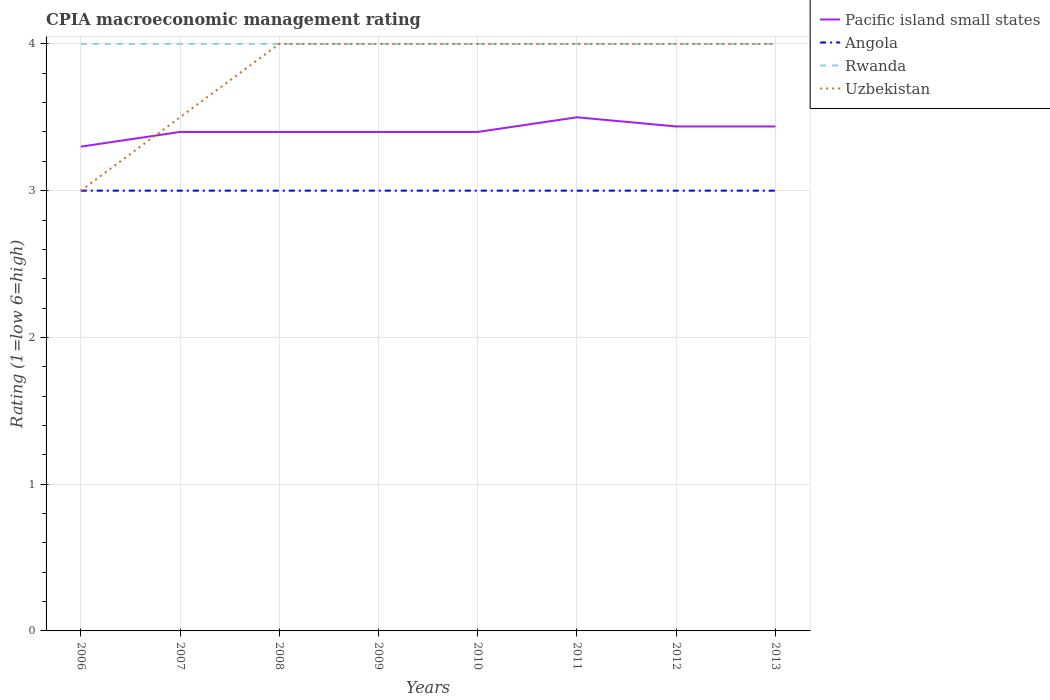Does the line corresponding to Rwanda intersect with the line corresponding to Uzbekistan?
Provide a succinct answer. Yes. Across all years, what is the maximum CPIA rating in Pacific island small states?
Provide a short and direct response. 3.3. What is the difference between the highest and the second highest CPIA rating in Uzbekistan?
Provide a succinct answer. 1. What is the difference between the highest and the lowest CPIA rating in Angola?
Your answer should be very brief. 0. Is the CPIA rating in Angola strictly greater than the CPIA rating in Uzbekistan over the years?
Make the answer very short. No. How many lines are there?
Offer a very short reply. 4. What is the difference between two consecutive major ticks on the Y-axis?
Give a very brief answer. 1. Does the graph contain grids?
Your answer should be compact. Yes. Where does the legend appear in the graph?
Your answer should be very brief. Top right. How are the legend labels stacked?
Your response must be concise. Vertical. What is the title of the graph?
Your answer should be very brief. CPIA macroeconomic management rating. Does "United States" appear as one of the legend labels in the graph?
Your answer should be compact. No. What is the label or title of the Y-axis?
Give a very brief answer. Rating (1=low 6=high). What is the Rating (1=low 6=high) in Uzbekistan in 2006?
Your answer should be very brief. 3. What is the Rating (1=low 6=high) in Rwanda in 2007?
Provide a succinct answer. 4. What is the Rating (1=low 6=high) of Uzbekistan in 2007?
Provide a short and direct response. 3.5. What is the Rating (1=low 6=high) in Angola in 2008?
Your answer should be very brief. 3. What is the Rating (1=low 6=high) in Rwanda in 2008?
Your answer should be very brief. 4. What is the Rating (1=low 6=high) in Uzbekistan in 2008?
Your response must be concise. 4. What is the Rating (1=low 6=high) in Pacific island small states in 2009?
Make the answer very short. 3.4. What is the Rating (1=low 6=high) in Rwanda in 2009?
Ensure brevity in your answer.  4. What is the Rating (1=low 6=high) in Pacific island small states in 2010?
Provide a short and direct response. 3.4. What is the Rating (1=low 6=high) of Uzbekistan in 2010?
Provide a short and direct response. 4. What is the Rating (1=low 6=high) of Pacific island small states in 2011?
Your answer should be compact. 3.5. What is the Rating (1=low 6=high) in Angola in 2011?
Ensure brevity in your answer.  3. What is the Rating (1=low 6=high) in Pacific island small states in 2012?
Provide a short and direct response. 3.44. What is the Rating (1=low 6=high) of Uzbekistan in 2012?
Provide a short and direct response. 4. What is the Rating (1=low 6=high) of Pacific island small states in 2013?
Give a very brief answer. 3.44. What is the Rating (1=low 6=high) of Rwanda in 2013?
Ensure brevity in your answer.  4. What is the Rating (1=low 6=high) in Uzbekistan in 2013?
Offer a very short reply. 4. Across all years, what is the maximum Rating (1=low 6=high) of Uzbekistan?
Offer a terse response. 4. Across all years, what is the minimum Rating (1=low 6=high) in Uzbekistan?
Provide a short and direct response. 3. What is the total Rating (1=low 6=high) of Pacific island small states in the graph?
Your answer should be very brief. 27.27. What is the total Rating (1=low 6=high) of Angola in the graph?
Give a very brief answer. 24. What is the total Rating (1=low 6=high) of Rwanda in the graph?
Keep it short and to the point. 32. What is the total Rating (1=low 6=high) in Uzbekistan in the graph?
Provide a short and direct response. 30.5. What is the difference between the Rating (1=low 6=high) of Pacific island small states in 2006 and that in 2007?
Ensure brevity in your answer.  -0.1. What is the difference between the Rating (1=low 6=high) of Uzbekistan in 2006 and that in 2007?
Offer a terse response. -0.5. What is the difference between the Rating (1=low 6=high) in Rwanda in 2006 and that in 2009?
Your answer should be very brief. 0. What is the difference between the Rating (1=low 6=high) in Uzbekistan in 2006 and that in 2009?
Your response must be concise. -1. What is the difference between the Rating (1=low 6=high) in Angola in 2006 and that in 2010?
Give a very brief answer. 0. What is the difference between the Rating (1=low 6=high) in Rwanda in 2006 and that in 2010?
Offer a terse response. 0. What is the difference between the Rating (1=low 6=high) in Pacific island small states in 2006 and that in 2011?
Ensure brevity in your answer.  -0.2. What is the difference between the Rating (1=low 6=high) of Angola in 2006 and that in 2011?
Ensure brevity in your answer.  0. What is the difference between the Rating (1=low 6=high) in Rwanda in 2006 and that in 2011?
Provide a short and direct response. 0. What is the difference between the Rating (1=low 6=high) in Pacific island small states in 2006 and that in 2012?
Offer a terse response. -0.14. What is the difference between the Rating (1=low 6=high) of Angola in 2006 and that in 2012?
Provide a succinct answer. 0. What is the difference between the Rating (1=low 6=high) of Rwanda in 2006 and that in 2012?
Ensure brevity in your answer.  0. What is the difference between the Rating (1=low 6=high) of Uzbekistan in 2006 and that in 2012?
Offer a terse response. -1. What is the difference between the Rating (1=low 6=high) of Pacific island small states in 2006 and that in 2013?
Provide a short and direct response. -0.14. What is the difference between the Rating (1=low 6=high) in Angola in 2006 and that in 2013?
Keep it short and to the point. 0. What is the difference between the Rating (1=low 6=high) of Uzbekistan in 2006 and that in 2013?
Your answer should be very brief. -1. What is the difference between the Rating (1=low 6=high) in Pacific island small states in 2007 and that in 2008?
Keep it short and to the point. 0. What is the difference between the Rating (1=low 6=high) of Uzbekistan in 2007 and that in 2008?
Your answer should be compact. -0.5. What is the difference between the Rating (1=low 6=high) in Pacific island small states in 2007 and that in 2009?
Keep it short and to the point. 0. What is the difference between the Rating (1=low 6=high) in Uzbekistan in 2007 and that in 2009?
Provide a succinct answer. -0.5. What is the difference between the Rating (1=low 6=high) of Rwanda in 2007 and that in 2010?
Provide a succinct answer. 0. What is the difference between the Rating (1=low 6=high) of Angola in 2007 and that in 2011?
Make the answer very short. 0. What is the difference between the Rating (1=low 6=high) in Rwanda in 2007 and that in 2011?
Make the answer very short. 0. What is the difference between the Rating (1=low 6=high) in Uzbekistan in 2007 and that in 2011?
Your answer should be compact. -0.5. What is the difference between the Rating (1=low 6=high) in Pacific island small states in 2007 and that in 2012?
Offer a very short reply. -0.04. What is the difference between the Rating (1=low 6=high) in Rwanda in 2007 and that in 2012?
Give a very brief answer. 0. What is the difference between the Rating (1=low 6=high) in Pacific island small states in 2007 and that in 2013?
Offer a very short reply. -0.04. What is the difference between the Rating (1=low 6=high) of Angola in 2007 and that in 2013?
Ensure brevity in your answer.  0. What is the difference between the Rating (1=low 6=high) in Pacific island small states in 2008 and that in 2009?
Keep it short and to the point. 0. What is the difference between the Rating (1=low 6=high) in Rwanda in 2008 and that in 2009?
Your response must be concise. 0. What is the difference between the Rating (1=low 6=high) in Uzbekistan in 2008 and that in 2010?
Provide a succinct answer. 0. What is the difference between the Rating (1=low 6=high) in Rwanda in 2008 and that in 2011?
Your response must be concise. 0. What is the difference between the Rating (1=low 6=high) of Pacific island small states in 2008 and that in 2012?
Provide a short and direct response. -0.04. What is the difference between the Rating (1=low 6=high) of Angola in 2008 and that in 2012?
Keep it short and to the point. 0. What is the difference between the Rating (1=low 6=high) in Rwanda in 2008 and that in 2012?
Your answer should be very brief. 0. What is the difference between the Rating (1=low 6=high) in Uzbekistan in 2008 and that in 2012?
Offer a very short reply. 0. What is the difference between the Rating (1=low 6=high) of Pacific island small states in 2008 and that in 2013?
Provide a succinct answer. -0.04. What is the difference between the Rating (1=low 6=high) of Angola in 2008 and that in 2013?
Offer a terse response. 0. What is the difference between the Rating (1=low 6=high) in Rwanda in 2008 and that in 2013?
Your answer should be compact. 0. What is the difference between the Rating (1=low 6=high) of Angola in 2009 and that in 2010?
Your answer should be very brief. 0. What is the difference between the Rating (1=low 6=high) in Rwanda in 2009 and that in 2010?
Give a very brief answer. 0. What is the difference between the Rating (1=low 6=high) of Uzbekistan in 2009 and that in 2010?
Ensure brevity in your answer.  0. What is the difference between the Rating (1=low 6=high) in Pacific island small states in 2009 and that in 2011?
Your answer should be very brief. -0.1. What is the difference between the Rating (1=low 6=high) of Angola in 2009 and that in 2011?
Your answer should be compact. 0. What is the difference between the Rating (1=low 6=high) in Rwanda in 2009 and that in 2011?
Your answer should be very brief. 0. What is the difference between the Rating (1=low 6=high) of Pacific island small states in 2009 and that in 2012?
Provide a succinct answer. -0.04. What is the difference between the Rating (1=low 6=high) of Angola in 2009 and that in 2012?
Provide a succinct answer. 0. What is the difference between the Rating (1=low 6=high) in Pacific island small states in 2009 and that in 2013?
Provide a succinct answer. -0.04. What is the difference between the Rating (1=low 6=high) in Angola in 2009 and that in 2013?
Ensure brevity in your answer.  0. What is the difference between the Rating (1=low 6=high) of Rwanda in 2009 and that in 2013?
Make the answer very short. 0. What is the difference between the Rating (1=low 6=high) in Uzbekistan in 2009 and that in 2013?
Your answer should be very brief. 0. What is the difference between the Rating (1=low 6=high) of Pacific island small states in 2010 and that in 2012?
Offer a very short reply. -0.04. What is the difference between the Rating (1=low 6=high) in Angola in 2010 and that in 2012?
Your answer should be compact. 0. What is the difference between the Rating (1=low 6=high) of Uzbekistan in 2010 and that in 2012?
Provide a short and direct response. 0. What is the difference between the Rating (1=low 6=high) of Pacific island small states in 2010 and that in 2013?
Ensure brevity in your answer.  -0.04. What is the difference between the Rating (1=low 6=high) in Rwanda in 2010 and that in 2013?
Your answer should be very brief. 0. What is the difference between the Rating (1=low 6=high) in Pacific island small states in 2011 and that in 2012?
Your answer should be very brief. 0.06. What is the difference between the Rating (1=low 6=high) of Angola in 2011 and that in 2012?
Make the answer very short. 0. What is the difference between the Rating (1=low 6=high) in Rwanda in 2011 and that in 2012?
Give a very brief answer. 0. What is the difference between the Rating (1=low 6=high) of Pacific island small states in 2011 and that in 2013?
Make the answer very short. 0.06. What is the difference between the Rating (1=low 6=high) in Angola in 2011 and that in 2013?
Your answer should be very brief. 0. What is the difference between the Rating (1=low 6=high) of Rwanda in 2011 and that in 2013?
Provide a short and direct response. 0. What is the difference between the Rating (1=low 6=high) of Uzbekistan in 2011 and that in 2013?
Your answer should be very brief. 0. What is the difference between the Rating (1=low 6=high) in Rwanda in 2012 and that in 2013?
Your response must be concise. 0. What is the difference between the Rating (1=low 6=high) of Pacific island small states in 2006 and the Rating (1=low 6=high) of Angola in 2007?
Give a very brief answer. 0.3. What is the difference between the Rating (1=low 6=high) in Pacific island small states in 2006 and the Rating (1=low 6=high) in Rwanda in 2007?
Keep it short and to the point. -0.7. What is the difference between the Rating (1=low 6=high) of Pacific island small states in 2006 and the Rating (1=low 6=high) of Uzbekistan in 2007?
Your answer should be very brief. -0.2. What is the difference between the Rating (1=low 6=high) of Angola in 2006 and the Rating (1=low 6=high) of Rwanda in 2007?
Your response must be concise. -1. What is the difference between the Rating (1=low 6=high) of Pacific island small states in 2006 and the Rating (1=low 6=high) of Rwanda in 2008?
Give a very brief answer. -0.7. What is the difference between the Rating (1=low 6=high) of Angola in 2006 and the Rating (1=low 6=high) of Uzbekistan in 2008?
Provide a succinct answer. -1. What is the difference between the Rating (1=low 6=high) of Pacific island small states in 2006 and the Rating (1=low 6=high) of Rwanda in 2009?
Your answer should be very brief. -0.7. What is the difference between the Rating (1=low 6=high) of Angola in 2006 and the Rating (1=low 6=high) of Rwanda in 2009?
Make the answer very short. -1. What is the difference between the Rating (1=low 6=high) in Pacific island small states in 2006 and the Rating (1=low 6=high) in Rwanda in 2010?
Offer a very short reply. -0.7. What is the difference between the Rating (1=low 6=high) of Angola in 2006 and the Rating (1=low 6=high) of Rwanda in 2010?
Your response must be concise. -1. What is the difference between the Rating (1=low 6=high) of Angola in 2006 and the Rating (1=low 6=high) of Uzbekistan in 2010?
Offer a very short reply. -1. What is the difference between the Rating (1=low 6=high) of Rwanda in 2006 and the Rating (1=low 6=high) of Uzbekistan in 2010?
Make the answer very short. 0. What is the difference between the Rating (1=low 6=high) in Angola in 2006 and the Rating (1=low 6=high) in Uzbekistan in 2011?
Your answer should be compact. -1. What is the difference between the Rating (1=low 6=high) in Pacific island small states in 2006 and the Rating (1=low 6=high) in Angola in 2012?
Offer a terse response. 0.3. What is the difference between the Rating (1=low 6=high) in Pacific island small states in 2006 and the Rating (1=low 6=high) in Angola in 2013?
Your response must be concise. 0.3. What is the difference between the Rating (1=low 6=high) of Rwanda in 2006 and the Rating (1=low 6=high) of Uzbekistan in 2013?
Your answer should be compact. 0. What is the difference between the Rating (1=low 6=high) in Pacific island small states in 2007 and the Rating (1=low 6=high) in Rwanda in 2008?
Keep it short and to the point. -0.6. What is the difference between the Rating (1=low 6=high) of Angola in 2007 and the Rating (1=low 6=high) of Rwanda in 2008?
Provide a succinct answer. -1. What is the difference between the Rating (1=low 6=high) of Rwanda in 2007 and the Rating (1=low 6=high) of Uzbekistan in 2008?
Make the answer very short. 0. What is the difference between the Rating (1=low 6=high) in Pacific island small states in 2007 and the Rating (1=low 6=high) in Rwanda in 2009?
Make the answer very short. -0.6. What is the difference between the Rating (1=low 6=high) of Pacific island small states in 2007 and the Rating (1=low 6=high) of Uzbekistan in 2009?
Offer a very short reply. -0.6. What is the difference between the Rating (1=low 6=high) of Rwanda in 2007 and the Rating (1=low 6=high) of Uzbekistan in 2009?
Provide a succinct answer. 0. What is the difference between the Rating (1=low 6=high) in Angola in 2007 and the Rating (1=low 6=high) in Rwanda in 2010?
Your answer should be very brief. -1. What is the difference between the Rating (1=low 6=high) in Angola in 2007 and the Rating (1=low 6=high) in Uzbekistan in 2010?
Keep it short and to the point. -1. What is the difference between the Rating (1=low 6=high) of Rwanda in 2007 and the Rating (1=low 6=high) of Uzbekistan in 2010?
Your response must be concise. 0. What is the difference between the Rating (1=low 6=high) in Angola in 2007 and the Rating (1=low 6=high) in Rwanda in 2011?
Make the answer very short. -1. What is the difference between the Rating (1=low 6=high) in Rwanda in 2007 and the Rating (1=low 6=high) in Uzbekistan in 2011?
Offer a very short reply. 0. What is the difference between the Rating (1=low 6=high) of Pacific island small states in 2007 and the Rating (1=low 6=high) of Angola in 2012?
Your answer should be very brief. 0.4. What is the difference between the Rating (1=low 6=high) in Pacific island small states in 2007 and the Rating (1=low 6=high) in Uzbekistan in 2012?
Your response must be concise. -0.6. What is the difference between the Rating (1=low 6=high) of Angola in 2007 and the Rating (1=low 6=high) of Rwanda in 2012?
Make the answer very short. -1. What is the difference between the Rating (1=low 6=high) of Angola in 2007 and the Rating (1=low 6=high) of Uzbekistan in 2012?
Make the answer very short. -1. What is the difference between the Rating (1=low 6=high) of Angola in 2007 and the Rating (1=low 6=high) of Rwanda in 2013?
Ensure brevity in your answer.  -1. What is the difference between the Rating (1=low 6=high) of Pacific island small states in 2008 and the Rating (1=low 6=high) of Rwanda in 2009?
Your response must be concise. -0.6. What is the difference between the Rating (1=low 6=high) in Pacific island small states in 2008 and the Rating (1=low 6=high) in Uzbekistan in 2009?
Give a very brief answer. -0.6. What is the difference between the Rating (1=low 6=high) in Angola in 2008 and the Rating (1=low 6=high) in Rwanda in 2009?
Give a very brief answer. -1. What is the difference between the Rating (1=low 6=high) of Angola in 2008 and the Rating (1=low 6=high) of Uzbekistan in 2009?
Your response must be concise. -1. What is the difference between the Rating (1=low 6=high) of Pacific island small states in 2008 and the Rating (1=low 6=high) of Rwanda in 2010?
Your answer should be very brief. -0.6. What is the difference between the Rating (1=low 6=high) of Angola in 2008 and the Rating (1=low 6=high) of Uzbekistan in 2010?
Offer a very short reply. -1. What is the difference between the Rating (1=low 6=high) of Pacific island small states in 2008 and the Rating (1=low 6=high) of Angola in 2011?
Your answer should be compact. 0.4. What is the difference between the Rating (1=low 6=high) of Rwanda in 2008 and the Rating (1=low 6=high) of Uzbekistan in 2011?
Keep it short and to the point. 0. What is the difference between the Rating (1=low 6=high) of Pacific island small states in 2008 and the Rating (1=low 6=high) of Angola in 2012?
Offer a very short reply. 0.4. What is the difference between the Rating (1=low 6=high) of Pacific island small states in 2008 and the Rating (1=low 6=high) of Rwanda in 2012?
Your answer should be compact. -0.6. What is the difference between the Rating (1=low 6=high) in Angola in 2008 and the Rating (1=low 6=high) in Rwanda in 2012?
Offer a very short reply. -1. What is the difference between the Rating (1=low 6=high) in Angola in 2008 and the Rating (1=low 6=high) in Uzbekistan in 2012?
Make the answer very short. -1. What is the difference between the Rating (1=low 6=high) of Pacific island small states in 2008 and the Rating (1=low 6=high) of Angola in 2013?
Offer a very short reply. 0.4. What is the difference between the Rating (1=low 6=high) in Pacific island small states in 2008 and the Rating (1=low 6=high) in Rwanda in 2013?
Your answer should be very brief. -0.6. What is the difference between the Rating (1=low 6=high) of Pacific island small states in 2008 and the Rating (1=low 6=high) of Uzbekistan in 2013?
Your answer should be compact. -0.6. What is the difference between the Rating (1=low 6=high) of Angola in 2008 and the Rating (1=low 6=high) of Uzbekistan in 2013?
Give a very brief answer. -1. What is the difference between the Rating (1=low 6=high) in Rwanda in 2008 and the Rating (1=low 6=high) in Uzbekistan in 2013?
Your answer should be compact. 0. What is the difference between the Rating (1=low 6=high) of Pacific island small states in 2009 and the Rating (1=low 6=high) of Angola in 2010?
Give a very brief answer. 0.4. What is the difference between the Rating (1=low 6=high) in Pacific island small states in 2009 and the Rating (1=low 6=high) in Uzbekistan in 2010?
Make the answer very short. -0.6. What is the difference between the Rating (1=low 6=high) of Angola in 2009 and the Rating (1=low 6=high) of Rwanda in 2010?
Offer a terse response. -1. What is the difference between the Rating (1=low 6=high) of Rwanda in 2009 and the Rating (1=low 6=high) of Uzbekistan in 2010?
Make the answer very short. 0. What is the difference between the Rating (1=low 6=high) in Pacific island small states in 2009 and the Rating (1=low 6=high) in Angola in 2011?
Your answer should be very brief. 0.4. What is the difference between the Rating (1=low 6=high) in Pacific island small states in 2009 and the Rating (1=low 6=high) in Uzbekistan in 2012?
Give a very brief answer. -0.6. What is the difference between the Rating (1=low 6=high) of Angola in 2009 and the Rating (1=low 6=high) of Uzbekistan in 2012?
Your answer should be very brief. -1. What is the difference between the Rating (1=low 6=high) of Pacific island small states in 2009 and the Rating (1=low 6=high) of Angola in 2013?
Keep it short and to the point. 0.4. What is the difference between the Rating (1=low 6=high) in Pacific island small states in 2009 and the Rating (1=low 6=high) in Rwanda in 2013?
Provide a short and direct response. -0.6. What is the difference between the Rating (1=low 6=high) of Pacific island small states in 2009 and the Rating (1=low 6=high) of Uzbekistan in 2013?
Your answer should be compact. -0.6. What is the difference between the Rating (1=low 6=high) in Angola in 2009 and the Rating (1=low 6=high) in Rwanda in 2013?
Offer a terse response. -1. What is the difference between the Rating (1=low 6=high) of Angola in 2009 and the Rating (1=low 6=high) of Uzbekistan in 2013?
Make the answer very short. -1. What is the difference between the Rating (1=low 6=high) in Pacific island small states in 2010 and the Rating (1=low 6=high) in Rwanda in 2011?
Provide a short and direct response. -0.6. What is the difference between the Rating (1=low 6=high) of Pacific island small states in 2010 and the Rating (1=low 6=high) of Uzbekistan in 2011?
Ensure brevity in your answer.  -0.6. What is the difference between the Rating (1=low 6=high) of Angola in 2010 and the Rating (1=low 6=high) of Uzbekistan in 2011?
Keep it short and to the point. -1. What is the difference between the Rating (1=low 6=high) in Pacific island small states in 2010 and the Rating (1=low 6=high) in Angola in 2012?
Give a very brief answer. 0.4. What is the difference between the Rating (1=low 6=high) of Pacific island small states in 2010 and the Rating (1=low 6=high) of Rwanda in 2012?
Offer a very short reply. -0.6. What is the difference between the Rating (1=low 6=high) of Angola in 2010 and the Rating (1=low 6=high) of Rwanda in 2012?
Offer a terse response. -1. What is the difference between the Rating (1=low 6=high) of Angola in 2010 and the Rating (1=low 6=high) of Uzbekistan in 2012?
Your answer should be compact. -1. What is the difference between the Rating (1=low 6=high) in Rwanda in 2010 and the Rating (1=low 6=high) in Uzbekistan in 2012?
Your answer should be very brief. 0. What is the difference between the Rating (1=low 6=high) of Pacific island small states in 2010 and the Rating (1=low 6=high) of Rwanda in 2013?
Your answer should be compact. -0.6. What is the difference between the Rating (1=low 6=high) of Pacific island small states in 2010 and the Rating (1=low 6=high) of Uzbekistan in 2013?
Provide a succinct answer. -0.6. What is the difference between the Rating (1=low 6=high) in Angola in 2010 and the Rating (1=low 6=high) in Rwanda in 2013?
Your answer should be compact. -1. What is the difference between the Rating (1=low 6=high) in Rwanda in 2010 and the Rating (1=low 6=high) in Uzbekistan in 2013?
Make the answer very short. 0. What is the difference between the Rating (1=low 6=high) in Pacific island small states in 2011 and the Rating (1=low 6=high) in Angola in 2012?
Make the answer very short. 0.5. What is the difference between the Rating (1=low 6=high) of Pacific island small states in 2011 and the Rating (1=low 6=high) of Rwanda in 2012?
Offer a very short reply. -0.5. What is the difference between the Rating (1=low 6=high) of Pacific island small states in 2011 and the Rating (1=low 6=high) of Uzbekistan in 2012?
Offer a terse response. -0.5. What is the difference between the Rating (1=low 6=high) in Angola in 2011 and the Rating (1=low 6=high) in Rwanda in 2012?
Offer a terse response. -1. What is the difference between the Rating (1=low 6=high) of Rwanda in 2011 and the Rating (1=low 6=high) of Uzbekistan in 2012?
Provide a succinct answer. 0. What is the difference between the Rating (1=low 6=high) in Angola in 2011 and the Rating (1=low 6=high) in Rwanda in 2013?
Ensure brevity in your answer.  -1. What is the difference between the Rating (1=low 6=high) of Pacific island small states in 2012 and the Rating (1=low 6=high) of Angola in 2013?
Provide a short and direct response. 0.44. What is the difference between the Rating (1=low 6=high) of Pacific island small states in 2012 and the Rating (1=low 6=high) of Rwanda in 2013?
Offer a very short reply. -0.56. What is the difference between the Rating (1=low 6=high) of Pacific island small states in 2012 and the Rating (1=low 6=high) of Uzbekistan in 2013?
Your answer should be compact. -0.56. What is the average Rating (1=low 6=high) in Pacific island small states per year?
Provide a short and direct response. 3.41. What is the average Rating (1=low 6=high) in Uzbekistan per year?
Give a very brief answer. 3.81. In the year 2006, what is the difference between the Rating (1=low 6=high) of Pacific island small states and Rating (1=low 6=high) of Rwanda?
Your answer should be very brief. -0.7. In the year 2006, what is the difference between the Rating (1=low 6=high) of Angola and Rating (1=low 6=high) of Uzbekistan?
Give a very brief answer. 0. In the year 2006, what is the difference between the Rating (1=low 6=high) in Rwanda and Rating (1=low 6=high) in Uzbekistan?
Your response must be concise. 1. In the year 2007, what is the difference between the Rating (1=low 6=high) of Pacific island small states and Rating (1=low 6=high) of Uzbekistan?
Make the answer very short. -0.1. In the year 2007, what is the difference between the Rating (1=low 6=high) of Angola and Rating (1=low 6=high) of Uzbekistan?
Keep it short and to the point. -0.5. In the year 2007, what is the difference between the Rating (1=low 6=high) in Rwanda and Rating (1=low 6=high) in Uzbekistan?
Keep it short and to the point. 0.5. In the year 2008, what is the difference between the Rating (1=low 6=high) in Pacific island small states and Rating (1=low 6=high) in Angola?
Provide a succinct answer. 0.4. In the year 2008, what is the difference between the Rating (1=low 6=high) of Pacific island small states and Rating (1=low 6=high) of Rwanda?
Offer a terse response. -0.6. In the year 2008, what is the difference between the Rating (1=low 6=high) in Angola and Rating (1=low 6=high) in Rwanda?
Provide a short and direct response. -1. In the year 2008, what is the difference between the Rating (1=low 6=high) in Angola and Rating (1=low 6=high) in Uzbekistan?
Make the answer very short. -1. In the year 2009, what is the difference between the Rating (1=low 6=high) of Pacific island small states and Rating (1=low 6=high) of Uzbekistan?
Keep it short and to the point. -0.6. In the year 2009, what is the difference between the Rating (1=low 6=high) in Rwanda and Rating (1=low 6=high) in Uzbekistan?
Ensure brevity in your answer.  0. In the year 2010, what is the difference between the Rating (1=low 6=high) in Pacific island small states and Rating (1=low 6=high) in Rwanda?
Offer a very short reply. -0.6. In the year 2010, what is the difference between the Rating (1=low 6=high) of Pacific island small states and Rating (1=low 6=high) of Uzbekistan?
Offer a very short reply. -0.6. In the year 2011, what is the difference between the Rating (1=low 6=high) in Pacific island small states and Rating (1=low 6=high) in Uzbekistan?
Provide a succinct answer. -0.5. In the year 2011, what is the difference between the Rating (1=low 6=high) in Angola and Rating (1=low 6=high) in Rwanda?
Provide a succinct answer. -1. In the year 2011, what is the difference between the Rating (1=low 6=high) of Rwanda and Rating (1=low 6=high) of Uzbekistan?
Offer a terse response. 0. In the year 2012, what is the difference between the Rating (1=low 6=high) of Pacific island small states and Rating (1=low 6=high) of Angola?
Keep it short and to the point. 0.44. In the year 2012, what is the difference between the Rating (1=low 6=high) of Pacific island small states and Rating (1=low 6=high) of Rwanda?
Keep it short and to the point. -0.56. In the year 2012, what is the difference between the Rating (1=low 6=high) in Pacific island small states and Rating (1=low 6=high) in Uzbekistan?
Ensure brevity in your answer.  -0.56. In the year 2012, what is the difference between the Rating (1=low 6=high) in Angola and Rating (1=low 6=high) in Uzbekistan?
Keep it short and to the point. -1. In the year 2013, what is the difference between the Rating (1=low 6=high) of Pacific island small states and Rating (1=low 6=high) of Angola?
Your answer should be very brief. 0.44. In the year 2013, what is the difference between the Rating (1=low 6=high) in Pacific island small states and Rating (1=low 6=high) in Rwanda?
Provide a short and direct response. -0.56. In the year 2013, what is the difference between the Rating (1=low 6=high) of Pacific island small states and Rating (1=low 6=high) of Uzbekistan?
Your answer should be compact. -0.56. In the year 2013, what is the difference between the Rating (1=low 6=high) in Angola and Rating (1=low 6=high) in Uzbekistan?
Make the answer very short. -1. What is the ratio of the Rating (1=low 6=high) of Pacific island small states in 2006 to that in 2007?
Your response must be concise. 0.97. What is the ratio of the Rating (1=low 6=high) of Rwanda in 2006 to that in 2007?
Your answer should be compact. 1. What is the ratio of the Rating (1=low 6=high) of Pacific island small states in 2006 to that in 2008?
Give a very brief answer. 0.97. What is the ratio of the Rating (1=low 6=high) of Rwanda in 2006 to that in 2008?
Your answer should be very brief. 1. What is the ratio of the Rating (1=low 6=high) of Uzbekistan in 2006 to that in 2008?
Provide a short and direct response. 0.75. What is the ratio of the Rating (1=low 6=high) of Pacific island small states in 2006 to that in 2009?
Your answer should be very brief. 0.97. What is the ratio of the Rating (1=low 6=high) in Pacific island small states in 2006 to that in 2010?
Offer a very short reply. 0.97. What is the ratio of the Rating (1=low 6=high) of Angola in 2006 to that in 2010?
Provide a succinct answer. 1. What is the ratio of the Rating (1=low 6=high) in Uzbekistan in 2006 to that in 2010?
Keep it short and to the point. 0.75. What is the ratio of the Rating (1=low 6=high) of Pacific island small states in 2006 to that in 2011?
Ensure brevity in your answer.  0.94. What is the ratio of the Rating (1=low 6=high) of Rwanda in 2006 to that in 2011?
Provide a short and direct response. 1. What is the ratio of the Rating (1=low 6=high) of Uzbekistan in 2006 to that in 2011?
Offer a very short reply. 0.75. What is the ratio of the Rating (1=low 6=high) of Pacific island small states in 2006 to that in 2012?
Make the answer very short. 0.96. What is the ratio of the Rating (1=low 6=high) of Angola in 2006 to that in 2012?
Offer a terse response. 1. What is the ratio of the Rating (1=low 6=high) in Angola in 2006 to that in 2013?
Give a very brief answer. 1. What is the ratio of the Rating (1=low 6=high) in Rwanda in 2007 to that in 2008?
Give a very brief answer. 1. What is the ratio of the Rating (1=low 6=high) of Uzbekistan in 2007 to that in 2008?
Ensure brevity in your answer.  0.88. What is the ratio of the Rating (1=low 6=high) in Pacific island small states in 2007 to that in 2009?
Offer a very short reply. 1. What is the ratio of the Rating (1=low 6=high) in Angola in 2007 to that in 2009?
Offer a very short reply. 1. What is the ratio of the Rating (1=low 6=high) in Uzbekistan in 2007 to that in 2009?
Ensure brevity in your answer.  0.88. What is the ratio of the Rating (1=low 6=high) of Pacific island small states in 2007 to that in 2010?
Offer a very short reply. 1. What is the ratio of the Rating (1=low 6=high) in Rwanda in 2007 to that in 2010?
Keep it short and to the point. 1. What is the ratio of the Rating (1=low 6=high) in Pacific island small states in 2007 to that in 2011?
Ensure brevity in your answer.  0.97. What is the ratio of the Rating (1=low 6=high) in Angola in 2007 to that in 2011?
Keep it short and to the point. 1. What is the ratio of the Rating (1=low 6=high) in Rwanda in 2007 to that in 2011?
Keep it short and to the point. 1. What is the ratio of the Rating (1=low 6=high) of Uzbekistan in 2007 to that in 2012?
Keep it short and to the point. 0.88. What is the ratio of the Rating (1=low 6=high) in Angola in 2008 to that in 2009?
Provide a succinct answer. 1. What is the ratio of the Rating (1=low 6=high) of Pacific island small states in 2008 to that in 2010?
Keep it short and to the point. 1. What is the ratio of the Rating (1=low 6=high) of Angola in 2008 to that in 2010?
Provide a short and direct response. 1. What is the ratio of the Rating (1=low 6=high) of Rwanda in 2008 to that in 2010?
Offer a terse response. 1. What is the ratio of the Rating (1=low 6=high) in Pacific island small states in 2008 to that in 2011?
Your answer should be very brief. 0.97. What is the ratio of the Rating (1=low 6=high) in Angola in 2008 to that in 2011?
Provide a short and direct response. 1. What is the ratio of the Rating (1=low 6=high) of Uzbekistan in 2008 to that in 2011?
Give a very brief answer. 1. What is the ratio of the Rating (1=low 6=high) in Angola in 2008 to that in 2012?
Your answer should be compact. 1. What is the ratio of the Rating (1=low 6=high) in Rwanda in 2008 to that in 2013?
Your response must be concise. 1. What is the ratio of the Rating (1=low 6=high) of Uzbekistan in 2008 to that in 2013?
Ensure brevity in your answer.  1. What is the ratio of the Rating (1=low 6=high) in Angola in 2009 to that in 2010?
Ensure brevity in your answer.  1. What is the ratio of the Rating (1=low 6=high) in Rwanda in 2009 to that in 2010?
Provide a succinct answer. 1. What is the ratio of the Rating (1=low 6=high) in Uzbekistan in 2009 to that in 2010?
Provide a short and direct response. 1. What is the ratio of the Rating (1=low 6=high) of Pacific island small states in 2009 to that in 2011?
Keep it short and to the point. 0.97. What is the ratio of the Rating (1=low 6=high) in Rwanda in 2009 to that in 2011?
Keep it short and to the point. 1. What is the ratio of the Rating (1=low 6=high) in Uzbekistan in 2009 to that in 2011?
Ensure brevity in your answer.  1. What is the ratio of the Rating (1=low 6=high) of Angola in 2009 to that in 2012?
Keep it short and to the point. 1. What is the ratio of the Rating (1=low 6=high) of Uzbekistan in 2009 to that in 2012?
Make the answer very short. 1. What is the ratio of the Rating (1=low 6=high) in Pacific island small states in 2009 to that in 2013?
Keep it short and to the point. 0.99. What is the ratio of the Rating (1=low 6=high) of Angola in 2009 to that in 2013?
Provide a succinct answer. 1. What is the ratio of the Rating (1=low 6=high) in Pacific island small states in 2010 to that in 2011?
Give a very brief answer. 0.97. What is the ratio of the Rating (1=low 6=high) in Pacific island small states in 2010 to that in 2012?
Your response must be concise. 0.99. What is the ratio of the Rating (1=low 6=high) in Rwanda in 2010 to that in 2012?
Make the answer very short. 1. What is the ratio of the Rating (1=low 6=high) in Uzbekistan in 2010 to that in 2012?
Keep it short and to the point. 1. What is the ratio of the Rating (1=low 6=high) in Angola in 2010 to that in 2013?
Give a very brief answer. 1. What is the ratio of the Rating (1=low 6=high) of Rwanda in 2010 to that in 2013?
Provide a succinct answer. 1. What is the ratio of the Rating (1=low 6=high) of Pacific island small states in 2011 to that in 2012?
Make the answer very short. 1.02. What is the ratio of the Rating (1=low 6=high) of Uzbekistan in 2011 to that in 2012?
Your answer should be very brief. 1. What is the ratio of the Rating (1=low 6=high) in Pacific island small states in 2011 to that in 2013?
Make the answer very short. 1.02. What is the ratio of the Rating (1=low 6=high) in Angola in 2011 to that in 2013?
Your answer should be compact. 1. What is the ratio of the Rating (1=low 6=high) in Rwanda in 2011 to that in 2013?
Offer a very short reply. 1. What is the ratio of the Rating (1=low 6=high) in Uzbekistan in 2011 to that in 2013?
Provide a short and direct response. 1. What is the ratio of the Rating (1=low 6=high) in Uzbekistan in 2012 to that in 2013?
Ensure brevity in your answer.  1. What is the difference between the highest and the second highest Rating (1=low 6=high) in Pacific island small states?
Your response must be concise. 0.06. What is the difference between the highest and the second highest Rating (1=low 6=high) in Angola?
Provide a succinct answer. 0. 